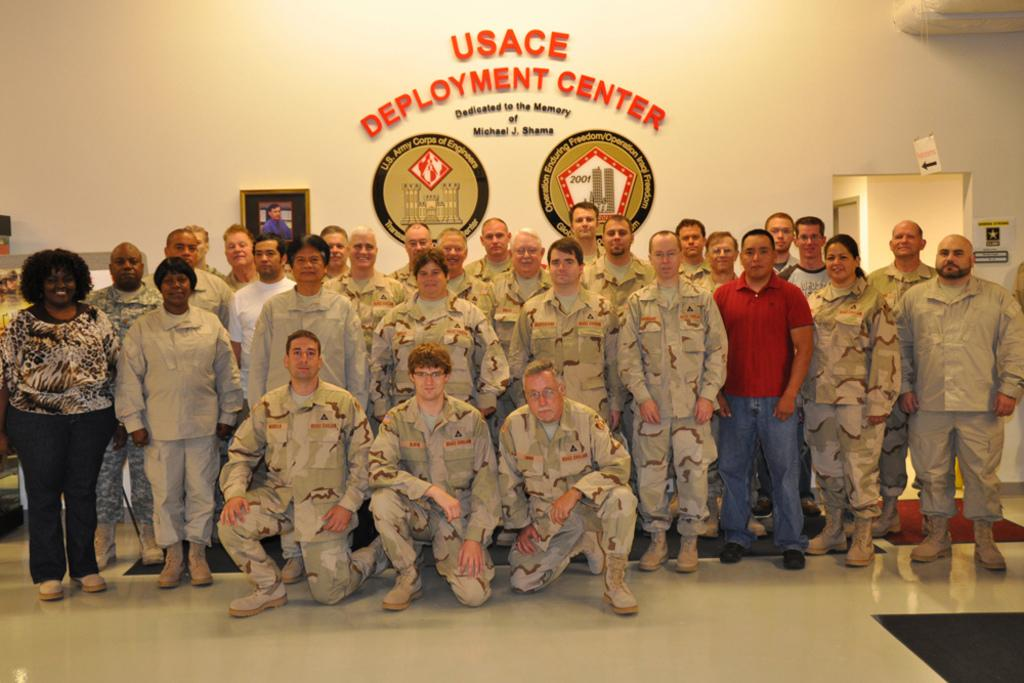How many people are in the image? There is a group of people in the image. What are three people doing in the image? Three people are in a squat position. Where are the people standing in the image? The people are standing on the floor. What can be seen in the background of the image? There is a frame and posters on the wall in the background. What type of fruit is hanging from the chain in the image? There is no chain or fruit present in the image. Is there a hospital visible in the image? No, there is no hospital visible in the image. 